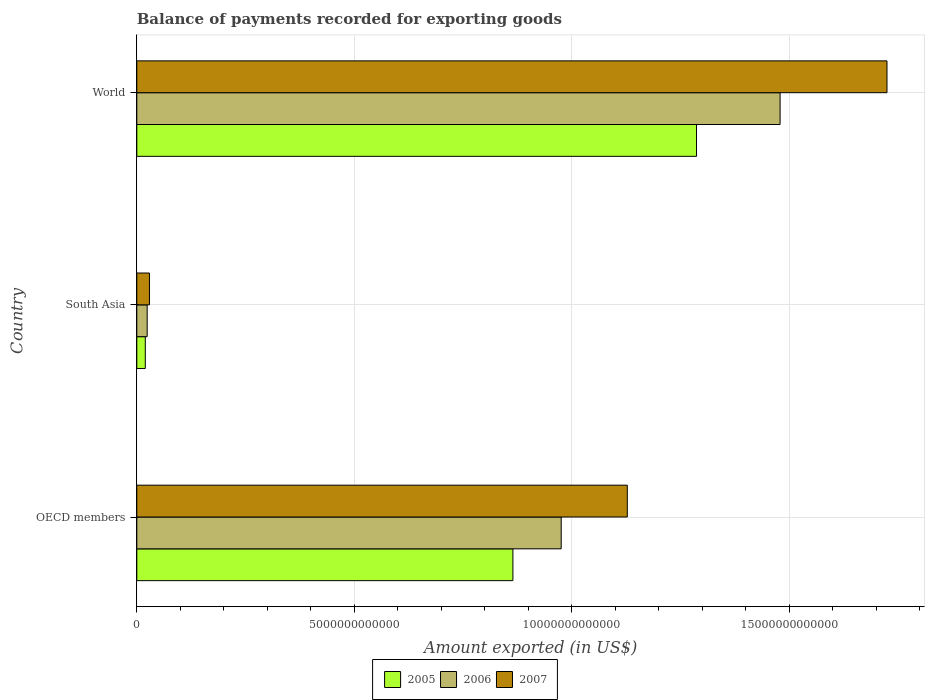Are the number of bars per tick equal to the number of legend labels?
Provide a short and direct response. Yes. Are the number of bars on each tick of the Y-axis equal?
Your answer should be compact. Yes. How many bars are there on the 2nd tick from the top?
Offer a very short reply. 3. What is the label of the 2nd group of bars from the top?
Offer a very short reply. South Asia. In how many cases, is the number of bars for a given country not equal to the number of legend labels?
Give a very brief answer. 0. What is the amount exported in 2006 in South Asia?
Ensure brevity in your answer.  2.39e+11. Across all countries, what is the maximum amount exported in 2007?
Make the answer very short. 1.72e+13. Across all countries, what is the minimum amount exported in 2007?
Provide a succinct answer. 2.91e+11. In which country was the amount exported in 2006 maximum?
Offer a terse response. World. In which country was the amount exported in 2005 minimum?
Ensure brevity in your answer.  South Asia. What is the total amount exported in 2007 in the graph?
Offer a very short reply. 2.88e+13. What is the difference between the amount exported in 2005 in OECD members and that in World?
Make the answer very short. -4.22e+12. What is the difference between the amount exported in 2007 in World and the amount exported in 2005 in OECD members?
Your answer should be compact. 8.60e+12. What is the average amount exported in 2005 per country?
Keep it short and to the point. 7.24e+12. What is the difference between the amount exported in 2005 and amount exported in 2006 in World?
Your answer should be very brief. -1.92e+12. In how many countries, is the amount exported in 2005 greater than 8000000000000 US$?
Provide a succinct answer. 2. What is the ratio of the amount exported in 2005 in OECD members to that in World?
Offer a very short reply. 0.67. Is the amount exported in 2006 in OECD members less than that in World?
Keep it short and to the point. Yes. Is the difference between the amount exported in 2005 in South Asia and World greater than the difference between the amount exported in 2006 in South Asia and World?
Make the answer very short. Yes. What is the difference between the highest and the second highest amount exported in 2006?
Offer a very short reply. 5.03e+12. What is the difference between the highest and the lowest amount exported in 2005?
Provide a succinct answer. 1.27e+13. Is the sum of the amount exported in 2007 in OECD members and World greater than the maximum amount exported in 2006 across all countries?
Your answer should be very brief. Yes. What does the 1st bar from the bottom in World represents?
Keep it short and to the point. 2005. How many bars are there?
Provide a short and direct response. 9. How many countries are there in the graph?
Your answer should be compact. 3. What is the difference between two consecutive major ticks on the X-axis?
Give a very brief answer. 5.00e+12. Are the values on the major ticks of X-axis written in scientific E-notation?
Your response must be concise. No. Does the graph contain any zero values?
Give a very brief answer. No. Does the graph contain grids?
Provide a short and direct response. Yes. How many legend labels are there?
Provide a short and direct response. 3. How are the legend labels stacked?
Your response must be concise. Horizontal. What is the title of the graph?
Provide a succinct answer. Balance of payments recorded for exporting goods. Does "2015" appear as one of the legend labels in the graph?
Provide a short and direct response. No. What is the label or title of the X-axis?
Keep it short and to the point. Amount exported (in US$). What is the label or title of the Y-axis?
Ensure brevity in your answer.  Country. What is the Amount exported (in US$) in 2005 in OECD members?
Give a very brief answer. 8.65e+12. What is the Amount exported (in US$) in 2006 in OECD members?
Your answer should be very brief. 9.76e+12. What is the Amount exported (in US$) of 2007 in OECD members?
Make the answer very short. 1.13e+13. What is the Amount exported (in US$) of 2005 in South Asia?
Provide a short and direct response. 1.95e+11. What is the Amount exported (in US$) in 2006 in South Asia?
Give a very brief answer. 2.39e+11. What is the Amount exported (in US$) of 2007 in South Asia?
Your response must be concise. 2.91e+11. What is the Amount exported (in US$) in 2005 in World?
Your response must be concise. 1.29e+13. What is the Amount exported (in US$) in 2006 in World?
Give a very brief answer. 1.48e+13. What is the Amount exported (in US$) of 2007 in World?
Give a very brief answer. 1.72e+13. Across all countries, what is the maximum Amount exported (in US$) of 2005?
Your answer should be compact. 1.29e+13. Across all countries, what is the maximum Amount exported (in US$) in 2006?
Provide a succinct answer. 1.48e+13. Across all countries, what is the maximum Amount exported (in US$) of 2007?
Your answer should be very brief. 1.72e+13. Across all countries, what is the minimum Amount exported (in US$) of 2005?
Provide a succinct answer. 1.95e+11. Across all countries, what is the minimum Amount exported (in US$) of 2006?
Keep it short and to the point. 2.39e+11. Across all countries, what is the minimum Amount exported (in US$) in 2007?
Provide a succinct answer. 2.91e+11. What is the total Amount exported (in US$) of 2005 in the graph?
Offer a terse response. 2.17e+13. What is the total Amount exported (in US$) in 2006 in the graph?
Your answer should be very brief. 2.48e+13. What is the total Amount exported (in US$) of 2007 in the graph?
Provide a succinct answer. 2.88e+13. What is the difference between the Amount exported (in US$) in 2005 in OECD members and that in South Asia?
Make the answer very short. 8.45e+12. What is the difference between the Amount exported (in US$) of 2006 in OECD members and that in South Asia?
Provide a succinct answer. 9.52e+12. What is the difference between the Amount exported (in US$) of 2007 in OECD members and that in South Asia?
Ensure brevity in your answer.  1.10e+13. What is the difference between the Amount exported (in US$) in 2005 in OECD members and that in World?
Give a very brief answer. -4.22e+12. What is the difference between the Amount exported (in US$) in 2006 in OECD members and that in World?
Offer a very short reply. -5.03e+12. What is the difference between the Amount exported (in US$) of 2007 in OECD members and that in World?
Ensure brevity in your answer.  -5.97e+12. What is the difference between the Amount exported (in US$) of 2005 in South Asia and that in World?
Ensure brevity in your answer.  -1.27e+13. What is the difference between the Amount exported (in US$) of 2006 in South Asia and that in World?
Make the answer very short. -1.46e+13. What is the difference between the Amount exported (in US$) of 2007 in South Asia and that in World?
Your answer should be compact. -1.70e+13. What is the difference between the Amount exported (in US$) of 2005 in OECD members and the Amount exported (in US$) of 2006 in South Asia?
Offer a very short reply. 8.41e+12. What is the difference between the Amount exported (in US$) in 2005 in OECD members and the Amount exported (in US$) in 2007 in South Asia?
Make the answer very short. 8.36e+12. What is the difference between the Amount exported (in US$) in 2006 in OECD members and the Amount exported (in US$) in 2007 in South Asia?
Ensure brevity in your answer.  9.47e+12. What is the difference between the Amount exported (in US$) in 2005 in OECD members and the Amount exported (in US$) in 2006 in World?
Your answer should be compact. -6.14e+12. What is the difference between the Amount exported (in US$) of 2005 in OECD members and the Amount exported (in US$) of 2007 in World?
Your answer should be compact. -8.60e+12. What is the difference between the Amount exported (in US$) of 2006 in OECD members and the Amount exported (in US$) of 2007 in World?
Your response must be concise. -7.49e+12. What is the difference between the Amount exported (in US$) of 2005 in South Asia and the Amount exported (in US$) of 2006 in World?
Provide a succinct answer. -1.46e+13. What is the difference between the Amount exported (in US$) in 2005 in South Asia and the Amount exported (in US$) in 2007 in World?
Offer a very short reply. -1.71e+13. What is the difference between the Amount exported (in US$) of 2006 in South Asia and the Amount exported (in US$) of 2007 in World?
Give a very brief answer. -1.70e+13. What is the average Amount exported (in US$) in 2005 per country?
Offer a very short reply. 7.24e+12. What is the average Amount exported (in US$) in 2006 per country?
Your response must be concise. 8.26e+12. What is the average Amount exported (in US$) of 2007 per country?
Ensure brevity in your answer.  9.60e+12. What is the difference between the Amount exported (in US$) in 2005 and Amount exported (in US$) in 2006 in OECD members?
Keep it short and to the point. -1.11e+12. What is the difference between the Amount exported (in US$) of 2005 and Amount exported (in US$) of 2007 in OECD members?
Provide a succinct answer. -2.63e+12. What is the difference between the Amount exported (in US$) in 2006 and Amount exported (in US$) in 2007 in OECD members?
Your response must be concise. -1.52e+12. What is the difference between the Amount exported (in US$) in 2005 and Amount exported (in US$) in 2006 in South Asia?
Make the answer very short. -4.30e+1. What is the difference between the Amount exported (in US$) in 2005 and Amount exported (in US$) in 2007 in South Asia?
Your answer should be very brief. -9.56e+1. What is the difference between the Amount exported (in US$) in 2006 and Amount exported (in US$) in 2007 in South Asia?
Make the answer very short. -5.26e+1. What is the difference between the Amount exported (in US$) in 2005 and Amount exported (in US$) in 2006 in World?
Offer a very short reply. -1.92e+12. What is the difference between the Amount exported (in US$) in 2005 and Amount exported (in US$) in 2007 in World?
Give a very brief answer. -4.38e+12. What is the difference between the Amount exported (in US$) of 2006 and Amount exported (in US$) of 2007 in World?
Provide a short and direct response. -2.46e+12. What is the ratio of the Amount exported (in US$) of 2005 in OECD members to that in South Asia?
Give a very brief answer. 44.23. What is the ratio of the Amount exported (in US$) of 2006 in OECD members to that in South Asia?
Your answer should be compact. 40.91. What is the ratio of the Amount exported (in US$) in 2007 in OECD members to that in South Asia?
Your answer should be compact. 38.74. What is the ratio of the Amount exported (in US$) of 2005 in OECD members to that in World?
Provide a short and direct response. 0.67. What is the ratio of the Amount exported (in US$) in 2006 in OECD members to that in World?
Keep it short and to the point. 0.66. What is the ratio of the Amount exported (in US$) of 2007 in OECD members to that in World?
Your answer should be very brief. 0.65. What is the ratio of the Amount exported (in US$) of 2005 in South Asia to that in World?
Your answer should be very brief. 0.02. What is the ratio of the Amount exported (in US$) of 2006 in South Asia to that in World?
Provide a short and direct response. 0.02. What is the ratio of the Amount exported (in US$) of 2007 in South Asia to that in World?
Offer a terse response. 0.02. What is the difference between the highest and the second highest Amount exported (in US$) in 2005?
Offer a very short reply. 4.22e+12. What is the difference between the highest and the second highest Amount exported (in US$) of 2006?
Ensure brevity in your answer.  5.03e+12. What is the difference between the highest and the second highest Amount exported (in US$) in 2007?
Give a very brief answer. 5.97e+12. What is the difference between the highest and the lowest Amount exported (in US$) of 2005?
Your answer should be very brief. 1.27e+13. What is the difference between the highest and the lowest Amount exported (in US$) in 2006?
Ensure brevity in your answer.  1.46e+13. What is the difference between the highest and the lowest Amount exported (in US$) of 2007?
Ensure brevity in your answer.  1.70e+13. 